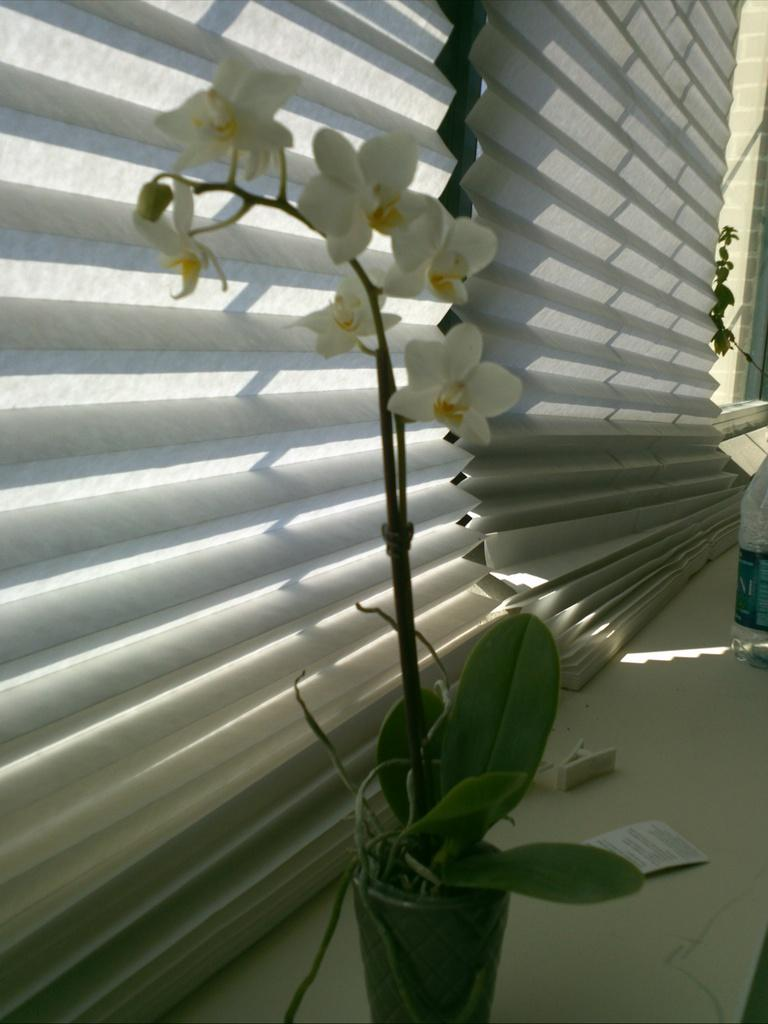What is located in the center of the image? There are plant pots in the center of the image. What colors are the flowers in the plant pots? The flowers in the plant pots are yellow and white. What can be seen in the background of the image? There is a wall and window blinds in the background of the image. How does the quiet cup affect the plant pots in the image? There is no mention of a quiet cup in the image, so it cannot affect the plant pots. 